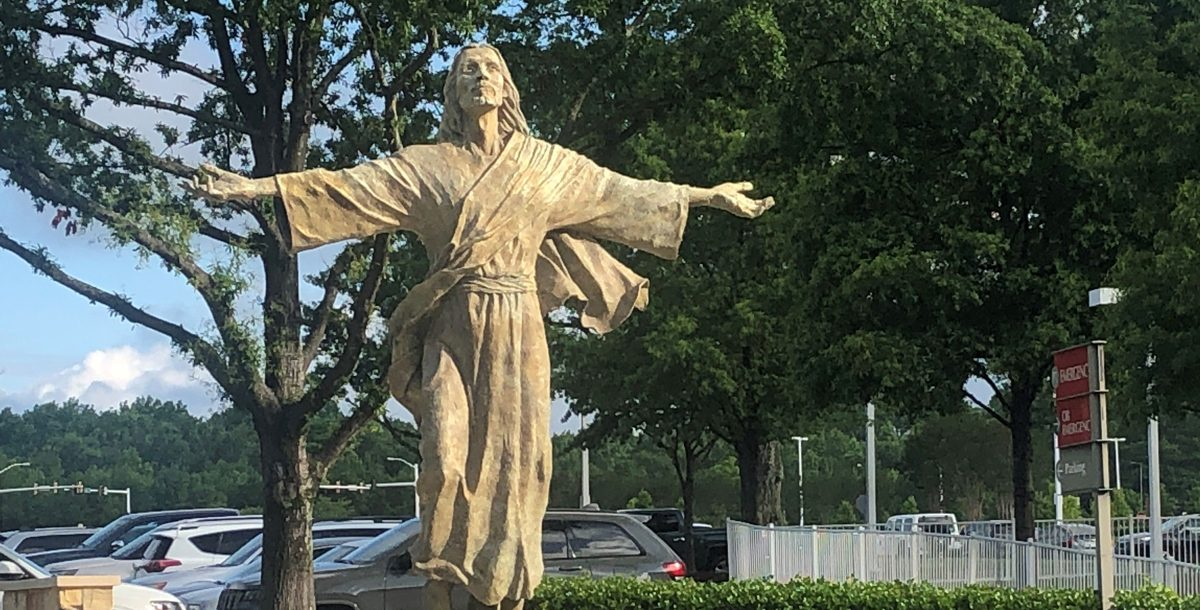Considering the placement and design of the statue, what might be the significance or purpose of this statue in its location, and how does it interact with its surroundings to convey its intended message or impression to onlookers? The statue is likely a representation of a historical or religious figure, given its traditional robe and the benevolent posture. Its placement in a public space suggests it's meant to be a focal point or a place for reflection. The openness of the figure's arms could be welcoming visitors or signifying an inclusive message. The interaction with the surrounding greenery and open sky may emphasize a connection with nature or the heavens, underscoring a sense of peace or inspiration. The fact that it's situated near a parking lot implies it's accessible to the public and serves as a landmark or point of interest for those who visit this area. 